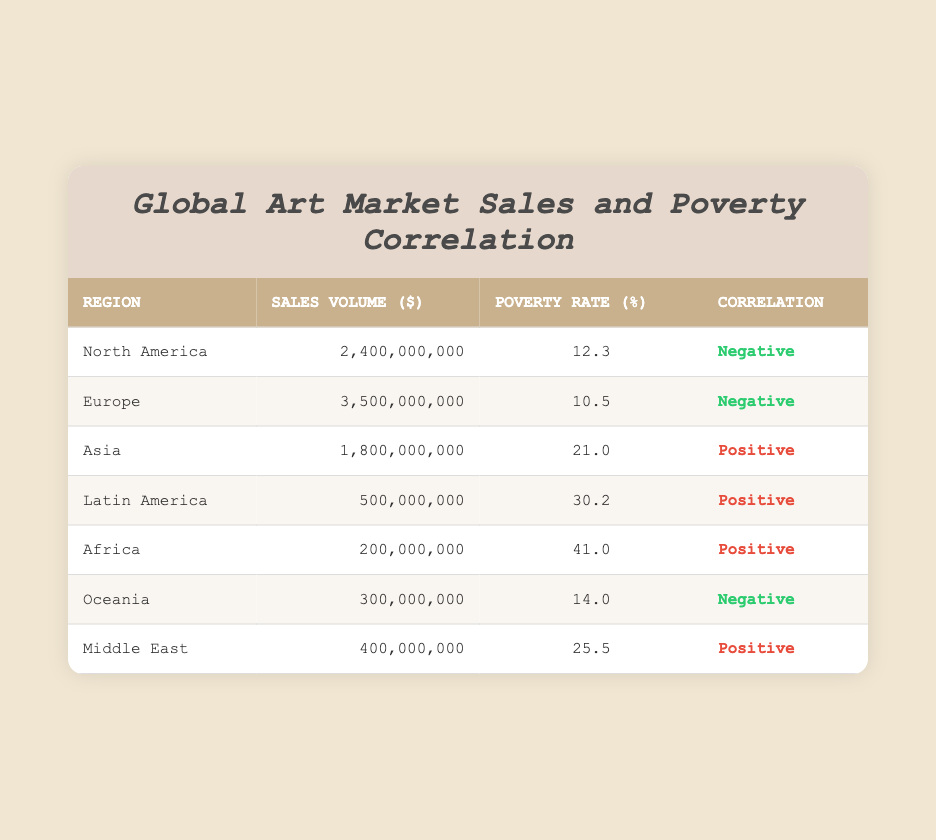What is the sales volume for Europe? The sales volume for Europe is listed directly in the table under the Sales Volume column for the Europe row. It shows 3,500,000,000.
Answer: 3,500,000,000 Which region has the highest poverty rate? By comparing the Poverty Rate column, Africa has the highest value at 41.0 when looking at all regions.
Answer: Africa Is there a correlation between high sales volume and low poverty rate in all regions? To answer this, we analyze the correlations: North America and Europe show negative correlations with low poverty rates, while Asia, Latin America, Africa, and the Middle East have positive correlations with higher poverty rates. Thus, across all regions, high sales volume does not consistently align with low poverty rates, indicating no unified correlation.
Answer: No What is the total sales volume for all regions combined? Adding the sales volumes from each region: 2,400,000,000 (North America) + 3,500,000,000 (Europe) + 1,800,000,000 (Asia) + 500,000,000 (Latin America) + 200,000,000 (Africa) + 300,000,000 (Oceania) + 400,000,000 (Middle East) gives a total sales volume of 9,100,000,000.
Answer: 9,100,000,000 Does the Middle East have a higher or lower poverty rate than Latin America? The Poverty Rate for the Middle East is 25.5 while for Latin America it is 30.2. Comparing these two values shows that the Middle East has a lower poverty rate than Latin America.
Answer: Lower Which regions show a positive correlation between sales volume and poverty rate? The regions that show a positive correlation according to the Correlation column are Asia, Latin America, Africa, and the Middle East. Table review directly indicates these correlations exist for these regions.
Answer: Asia, Latin America, Africa, Middle East 